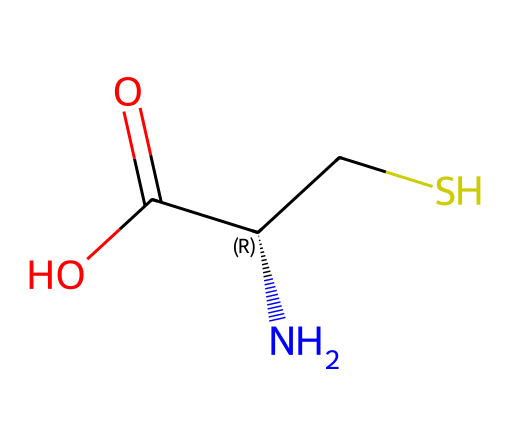What is the name of this chemical? The SMILES notation shows that this molecule contains the amino group (N), a carbon skeleton, a sulfhydryl group (CS), and a carboxylic acid group (C(=O)O). This corresponds to the structure of cysteine, which is a sulfur-containing amino acid.
Answer: cysteine How many carbon atoms are present in this structure? By analyzing the SMILES representation, the carbon atoms are indicated as part of the backbone and functional groups. There are three distinct carbon atoms: one in the amino group, one in the carboxylic acid, and one in the side chain containing the sulfur.
Answer: 3 What functional group is present due to the presence of sulfur? The sulfur atom (S) in the structure is part of a sulfhydryl (-SH) group, which is a characteristic functional group of thiol compounds. This influences the chemical properties of cysteine, such as its reactivity and ability to form disulfide bonds.
Answer: sulfhydryl What type of bond is likely formed between cysteine molecules? Cysteine contains a sulfhydryl group, which can undergo oxidation to form disulfide bonds between cysteine molecules. This type of bond is crucial in stabilizing protein structures, particularly in maintaining the tertiary and quaternary forms.
Answer: disulfide bond What is the total number of atoms in this molecule? Counting all atoms in the SMILES representation: there are 3 carbon atoms, 7 hydrogen atoms, 1 nitrogen atom, 1 oxygen atom, and 1 sulfur atom. Summing these gives a total of 13 atoms.
Answer: 13 Which characteristic makes cysteine an essential amino acid? Cysteine can be synthesized from other amino acids in the body; however, it becomes essential under certain conditions (like stress or illness) where the demand for cysteine exceeds its synthesis, making it crucial in protein synthesis and repair.
Answer: essential under certain conditions 